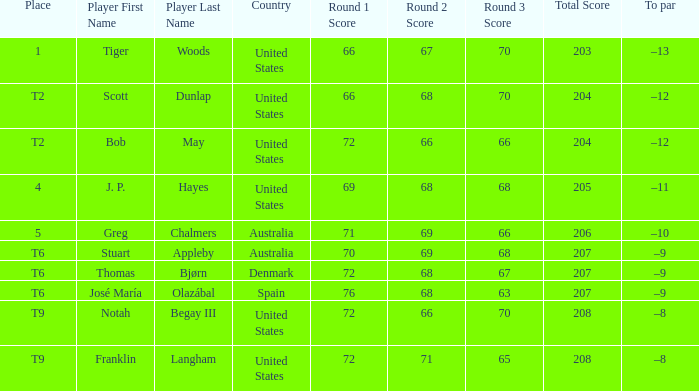Could you parse the entire table? {'header': ['Place', 'Player First Name', 'Player Last Name', 'Country', 'Round 1 Score', 'Round 2 Score', 'Round 3 Score', 'Total Score', 'To par'], 'rows': [['1', 'Tiger', 'Woods', 'United States', '66', '67', '70', '203', '–13'], ['T2', 'Scott', 'Dunlap', 'United States', '66', '68', '70', '204', '–12'], ['T2', 'Bob', 'May', 'United States', '72', '66', '66', '204', '–12'], ['4', 'J. P.', 'Hayes', 'United States', '69', '68', '68', '205', '–11'], ['5', 'Greg', 'Chalmers', 'Australia', '71', '69', '66', '206', '–10'], ['T6', 'Stuart', 'Appleby', 'Australia', '70', '69', '68', '207', '–9'], ['T6', 'Thomas', 'Bjørn', 'Denmark', '72', '68', '67', '207', '–9'], ['T6', 'José María', 'Olazábal', 'Spain', '76', '68', '63', '207', '–9'], ['T9', 'Notah', 'Begay III', 'United States', '72', '66', '70', '208', '–8'], ['T9', 'Franklin', 'Langham', 'United States', '72', '71', '65', '208', '–8']]} What is the place of the player with a 66-68-70=204 score? T2. 